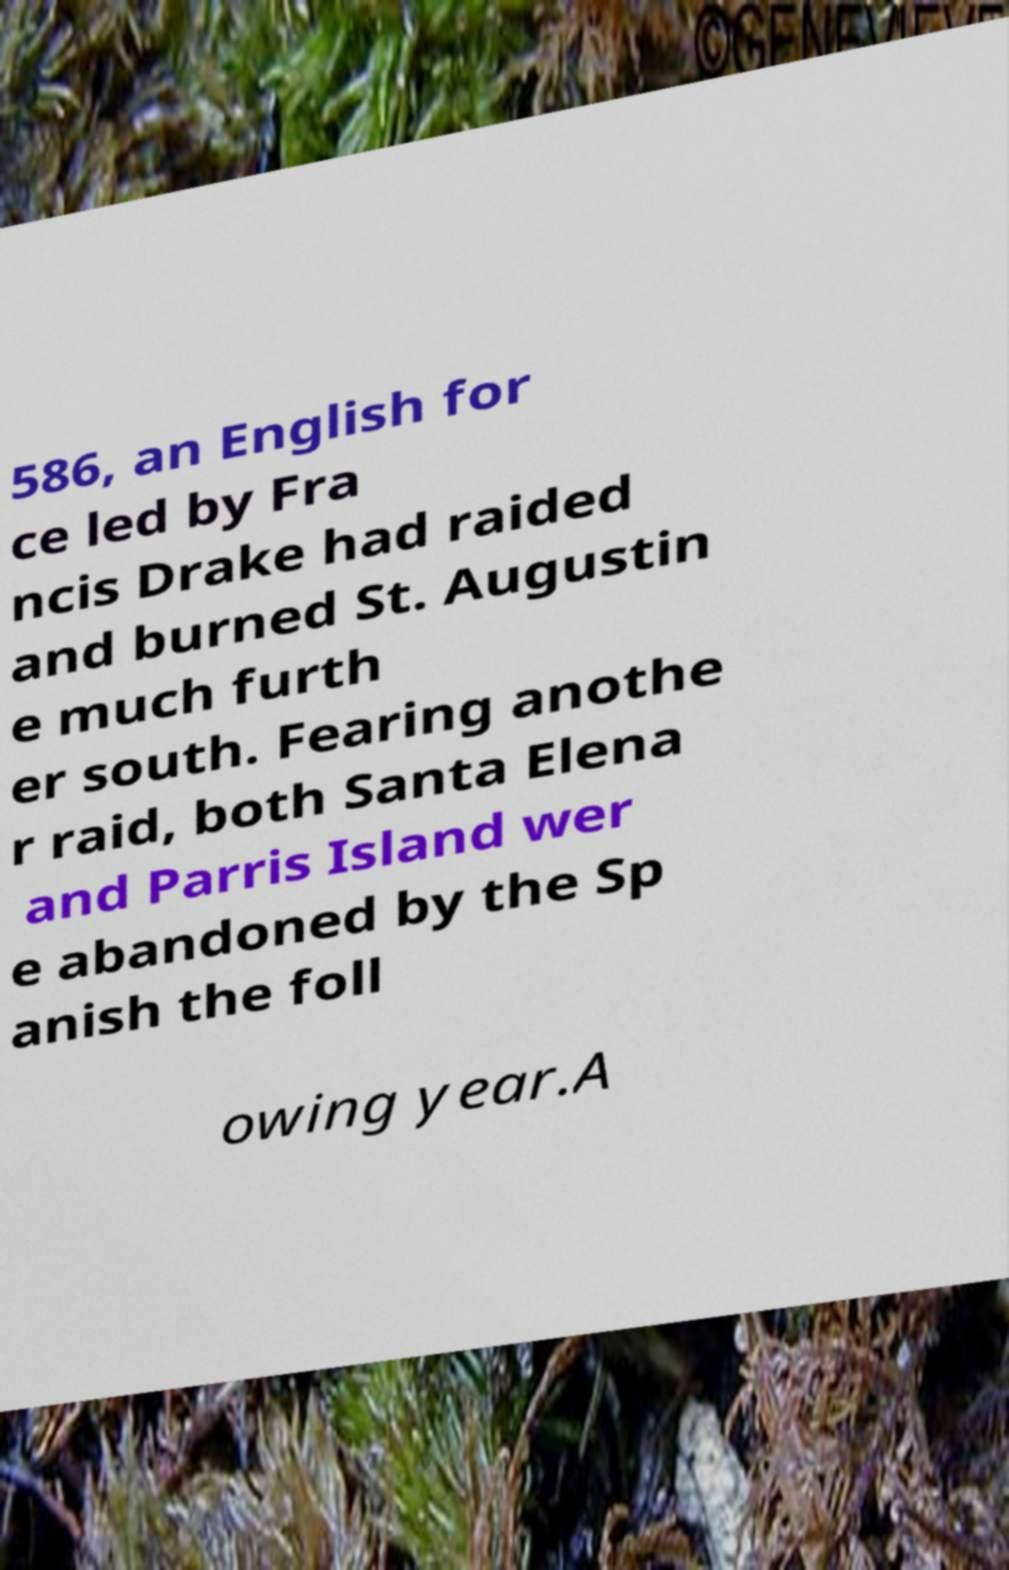Could you extract and type out the text from this image? 586, an English for ce led by Fra ncis Drake had raided and burned St. Augustin e much furth er south. Fearing anothe r raid, both Santa Elena and Parris Island wer e abandoned by the Sp anish the foll owing year.A 